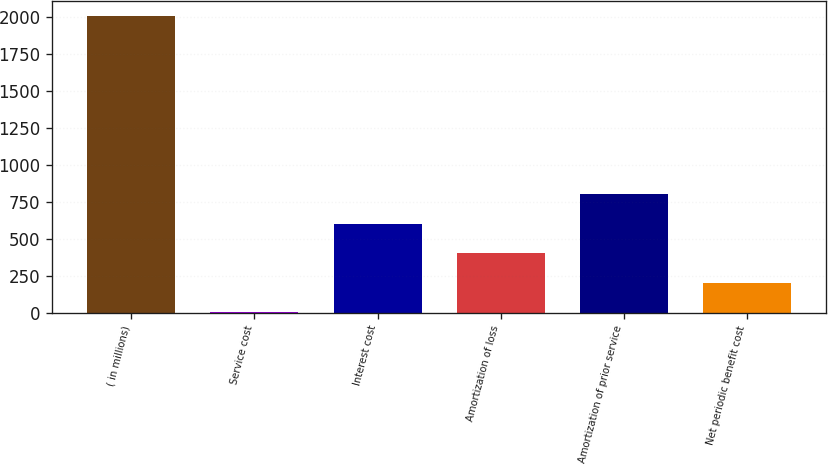Convert chart to OTSL. <chart><loc_0><loc_0><loc_500><loc_500><bar_chart><fcel>( in millions)<fcel>Service cost<fcel>Interest cost<fcel>Amortization of loss<fcel>Amortization of prior service<fcel>Net periodic benefit cost<nl><fcel>2006<fcel>0.9<fcel>602.43<fcel>401.92<fcel>802.94<fcel>201.41<nl></chart> 